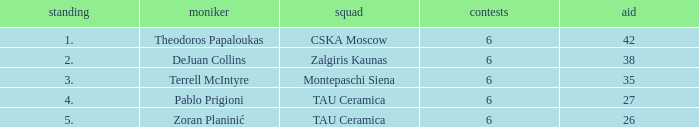What is the least number of assists among players ranked 2? 38.0. 